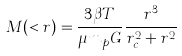Convert formula to latex. <formula><loc_0><loc_0><loc_500><loc_500>M ( < r ) = \frac { 3 \beta T } { \mu m _ { p } G } \frac { r ^ { 3 } } { r _ { c } ^ { 2 } + r ^ { 2 } }</formula> 